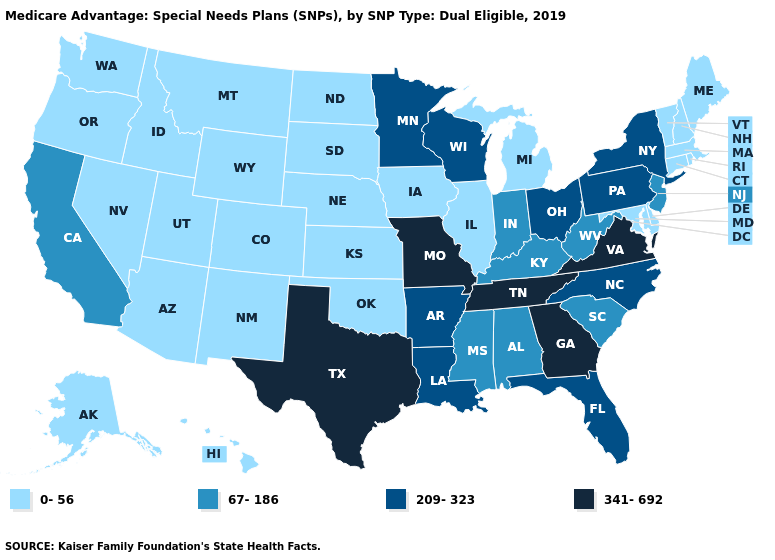Name the states that have a value in the range 341-692?
Write a very short answer. Georgia, Missouri, Tennessee, Texas, Virginia. Name the states that have a value in the range 341-692?
Be succinct. Georgia, Missouri, Tennessee, Texas, Virginia. Is the legend a continuous bar?
Concise answer only. No. What is the highest value in the USA?
Give a very brief answer. 341-692. What is the lowest value in the USA?
Answer briefly. 0-56. What is the value of Illinois?
Give a very brief answer. 0-56. Does California have the highest value in the West?
Concise answer only. Yes. Name the states that have a value in the range 67-186?
Write a very short answer. Alabama, California, Indiana, Kentucky, Mississippi, New Jersey, South Carolina, West Virginia. Name the states that have a value in the range 0-56?
Give a very brief answer. Alaska, Arizona, Colorado, Connecticut, Delaware, Hawaii, Idaho, Illinois, Iowa, Kansas, Maine, Maryland, Massachusetts, Michigan, Montana, Nebraska, Nevada, New Hampshire, New Mexico, North Dakota, Oklahoma, Oregon, Rhode Island, South Dakota, Utah, Vermont, Washington, Wyoming. Does Pennsylvania have the highest value in the USA?
Be succinct. No. What is the highest value in states that border Michigan?
Be succinct. 209-323. Name the states that have a value in the range 67-186?
Concise answer only. Alabama, California, Indiana, Kentucky, Mississippi, New Jersey, South Carolina, West Virginia. Name the states that have a value in the range 0-56?
Concise answer only. Alaska, Arizona, Colorado, Connecticut, Delaware, Hawaii, Idaho, Illinois, Iowa, Kansas, Maine, Maryland, Massachusetts, Michigan, Montana, Nebraska, Nevada, New Hampshire, New Mexico, North Dakota, Oklahoma, Oregon, Rhode Island, South Dakota, Utah, Vermont, Washington, Wyoming. What is the highest value in the USA?
Short answer required. 341-692. What is the value of Nevada?
Short answer required. 0-56. 